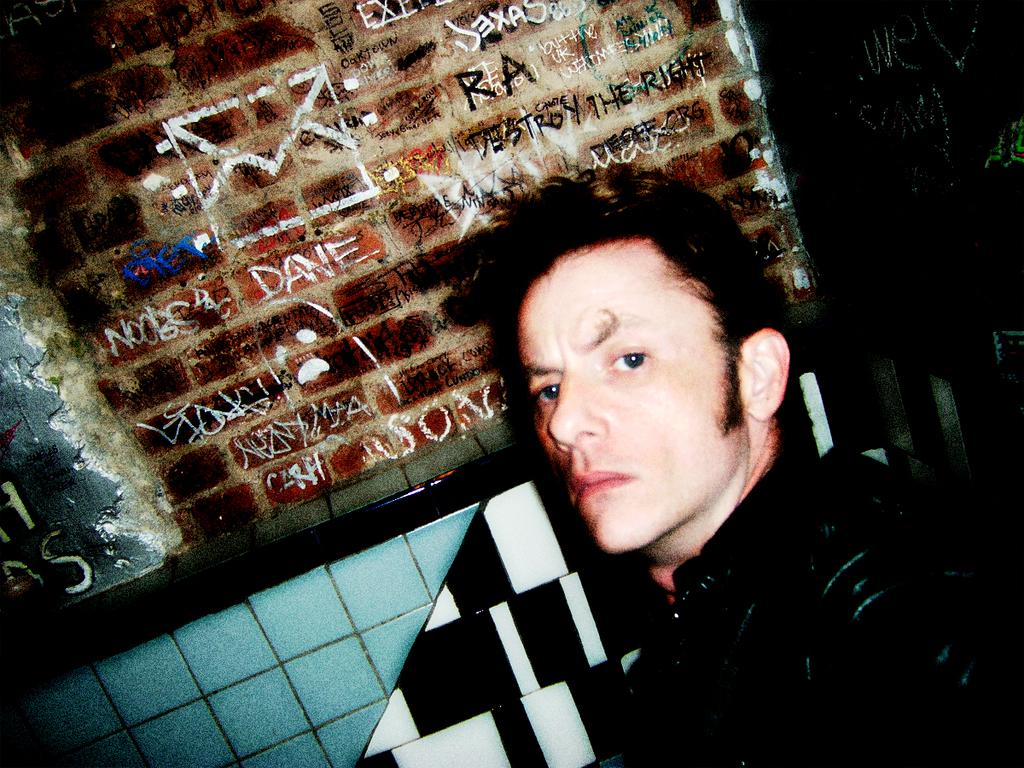What is the main subject of the image? There is a person in the image. What is the person doing in the image? The person is staring. Can you describe any additional details in the image? There is writing on a brick in the image. Is there any rain visible in the image? There is no rain present in the image; it only features a person staring and writing on a brick. 